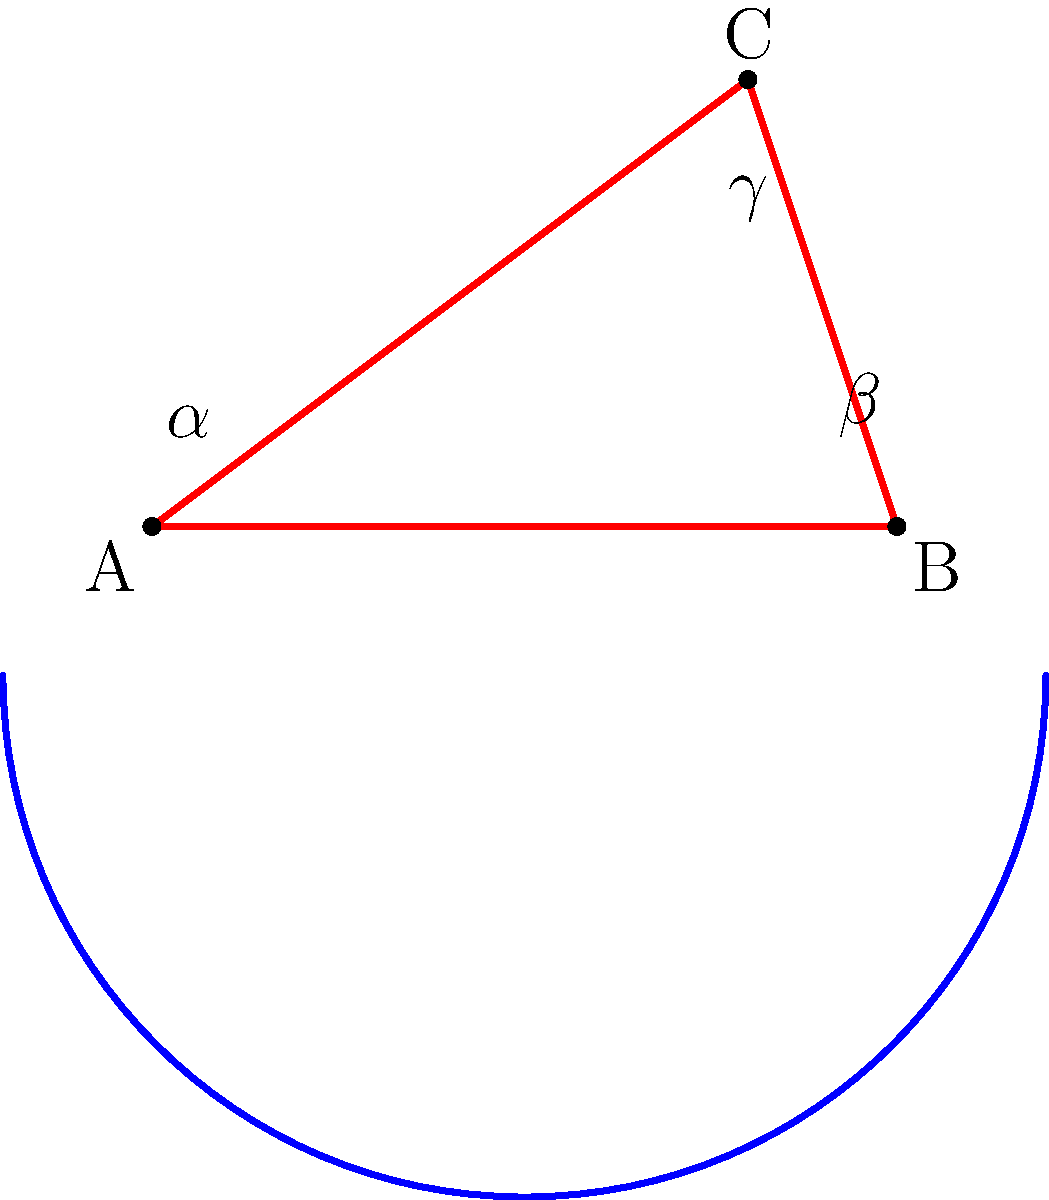Consider the frame geometry of a vintage motorcycle represented by the red triangle ABC on a negatively curved surface (blue curve). If the sum of the interior angles ($\alpha + \beta + \gamma$) in this non-Euclidean setting is measured to be 150°, what is the approximate Gaussian curvature $K$ of the surface at the location of the triangle, assuming the triangle is small relative to the curvature of the surface? To solve this problem, we'll use the Gauss-Bonnet theorem, which relates the sum of angles in a triangle on a curved surface to the Gaussian curvature of that surface.

Step 1: Recall the Gauss-Bonnet theorem for a triangle on a curved surface:
$$\alpha + \beta + \gamma = \pi + \int\int_A K dA$$
Where $A$ is the area of the triangle and $K$ is the Gaussian curvature.

Step 2: Convert the given angle sum to radians:
$$150° = \frac{5\pi}{6} \text{ radians}$$

Step 3: Substitute the known values into the Gauss-Bonnet theorem:
$$\frac{5\pi}{6} = \pi + KA$$
Where we assume $K$ is approximately constant over the small area $A$ of the triangle.

Step 4: Solve for $KA$:
$$KA = \frac{5\pi}{6} - \pi = -\frac{\pi}{6}$$

Step 5: Divide both sides by $A$ to isolate $K$:
$$K = -\frac{\pi}{6A}$$

Step 6: Since we don't know the exact area of the triangle, we can express the result in terms of the area:
$$K = -\frac{\pi}{6A} \approx -0.52/A$$

This negative value confirms that the surface has negative curvature, consistent with the visual representation in the diagram.
Answer: $K \approx -0.52/A$, where $A$ is the area of the triangle 